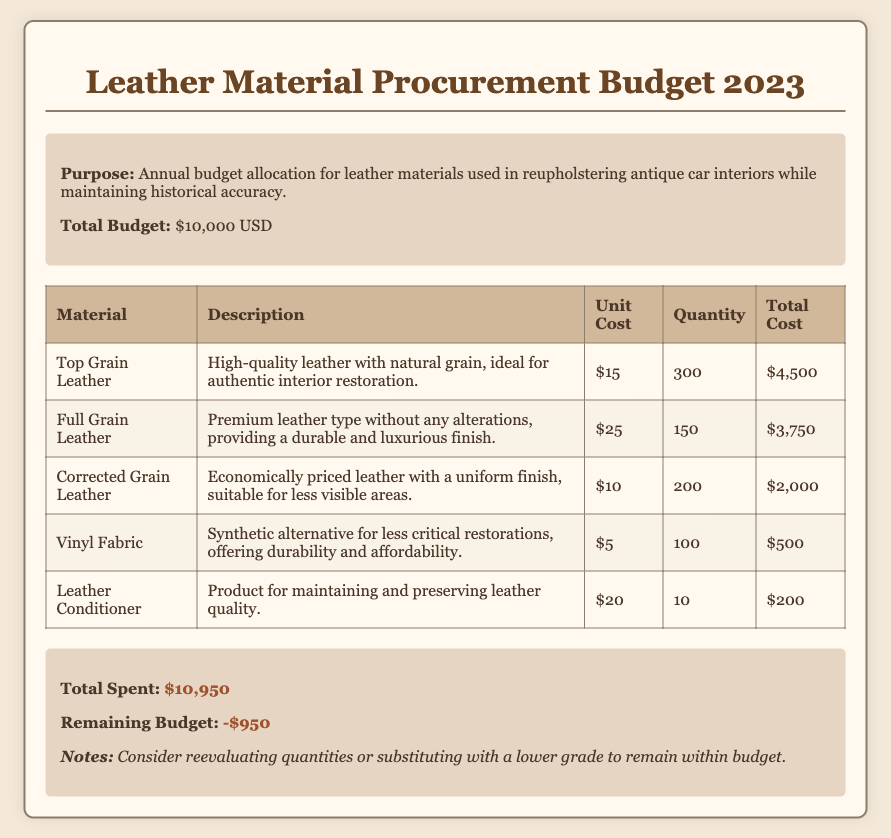What is the total budget? The total budget allocated for leather materials in the document is stated clearly.
Answer: $10,000 USD How much does Top Grain Leather cost per unit? The unit cost for Top Grain Leather is provided in the table.
Answer: $15 What is the quantity of Full Grain Leather being procured? The quantity listed for Full Grain Leather is found in the table.
Answer: 150 What is the total cost for Corrected Grain Leather? The total cost for Corrected Grain Leather can be calculated from the unit cost and quantity given in the table.
Answer: $2,000 What is the purpose of this budget? The document outlines the specific purpose for the budget allocation at the beginning.
Answer: Annual budget allocation for leather materials What is the remaining budget after all allocations? The document states the remaining budget after expenses have been summed up.
Answer: -$950 How many units of Vinyl Fabric are included in the procurement? The number of units for Vinyl Fabric is indicated in the table of materials.
Answer: 100 What is the expense for Leather Conditioner? The total cost of Leather Conditioner can be extracted from the data in the table.
Answer: $200 Why might the budget need reevaluation? The notes section provides reasoning for considering budget adjustments.
Answer: To remain within budget 